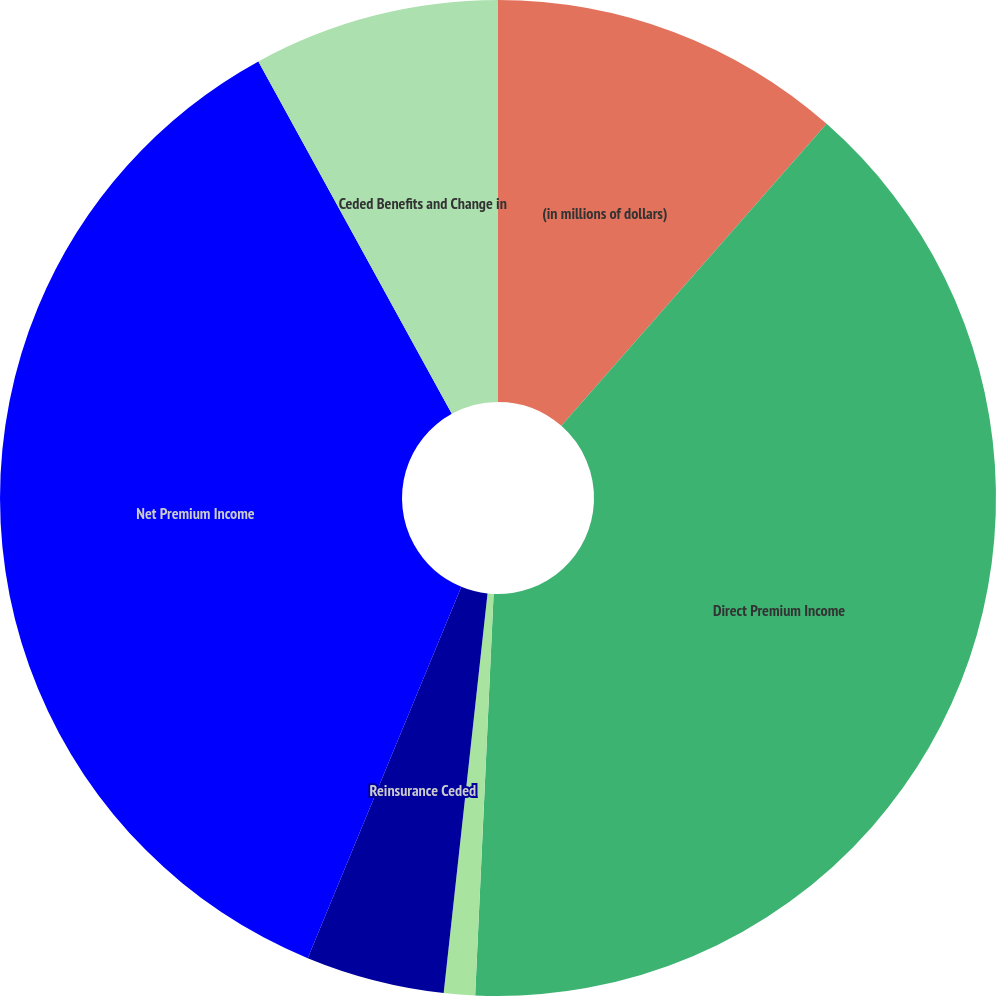Convert chart. <chart><loc_0><loc_0><loc_500><loc_500><pie_chart><fcel>(in millions of dollars)<fcel>Direct Premium Income<fcel>Reinsurance Assumed<fcel>Reinsurance Ceded<fcel>Net Premium Income<fcel>Ceded Benefits and Change in<nl><fcel>11.47%<fcel>39.26%<fcel>1.01%<fcel>4.5%<fcel>35.77%<fcel>7.99%<nl></chart> 